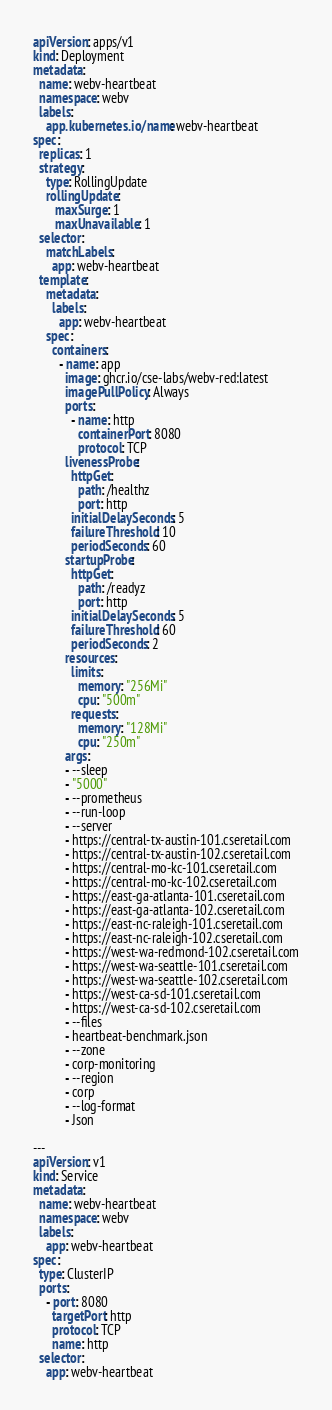Convert code to text. <code><loc_0><loc_0><loc_500><loc_500><_YAML_>apiVersion: apps/v1
kind: Deployment
metadata:
  name: webv-heartbeat
  namespace: webv
  labels:
    app.kubernetes.io/name: webv-heartbeat
spec:
  replicas: 1
  strategy:
    type: RollingUpdate
    rollingUpdate:
       maxSurge: 1
       maxUnavailable: 1
  selector:
    matchLabels:
      app: webv-heartbeat
  template:
    metadata:
      labels:
        app: webv-heartbeat
    spec:
      containers:
        - name: app
          image: ghcr.io/cse-labs/webv-red:latest
          imagePullPolicy: Always
          ports:
            - name: http
              containerPort: 8080
              protocol: TCP
          livenessProbe:
            httpGet:
              path: /healthz
              port: http
            initialDelaySeconds: 5
            failureThreshold: 10
            periodSeconds: 60
          startupProbe:
            httpGet:
              path: /readyz
              port: http
            initialDelaySeconds: 5
            failureThreshold: 60
            periodSeconds: 2
          resources:
            limits:
              memory: "256Mi"
              cpu: "500m"
            requests:
              memory: "128Mi"
              cpu: "250m"
          args:
          - --sleep
          - "5000"
          - --prometheus
          - --run-loop
          - --server
          - https://central-tx-austin-101.cseretail.com
          - https://central-tx-austin-102.cseretail.com
          - https://central-mo-kc-101.cseretail.com
          - https://central-mo-kc-102.cseretail.com
          - https://east-ga-atlanta-101.cseretail.com
          - https://east-ga-atlanta-102.cseretail.com
          - https://east-nc-raleigh-101.cseretail.com
          - https://east-nc-raleigh-102.cseretail.com
          - https://west-wa-redmond-102.cseretail.com
          - https://west-wa-seattle-101.cseretail.com
          - https://west-wa-seattle-102.cseretail.com
          - https://west-ca-sd-101.cseretail.com
          - https://west-ca-sd-102.cseretail.com
          - --files
          - heartbeat-benchmark.json
          - --zone
          - corp-monitoring
          - --region
          - corp
          - --log-format
          - Json

---
apiVersion: v1
kind: Service
metadata:
  name: webv-heartbeat
  namespace: webv
  labels:
    app: webv-heartbeat
spec:
  type: ClusterIP
  ports:
    - port: 8080
      targetPort: http
      protocol: TCP
      name: http
  selector:
    app: webv-heartbeat
</code> 